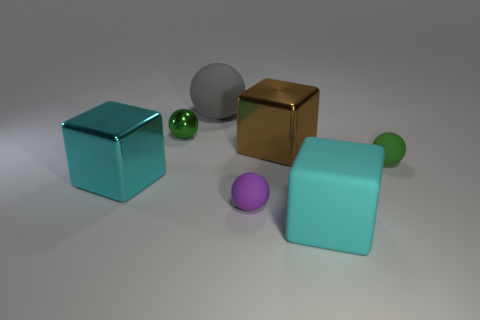Add 2 tiny purple balls. How many objects exist? 9 Subtract all spheres. How many objects are left? 3 Add 5 large metal objects. How many large metal objects exist? 7 Subtract 0 yellow cylinders. How many objects are left? 7 Subtract all small red metallic blocks. Subtract all big cyan cubes. How many objects are left? 5 Add 7 big cyan matte things. How many big cyan matte things are left? 8 